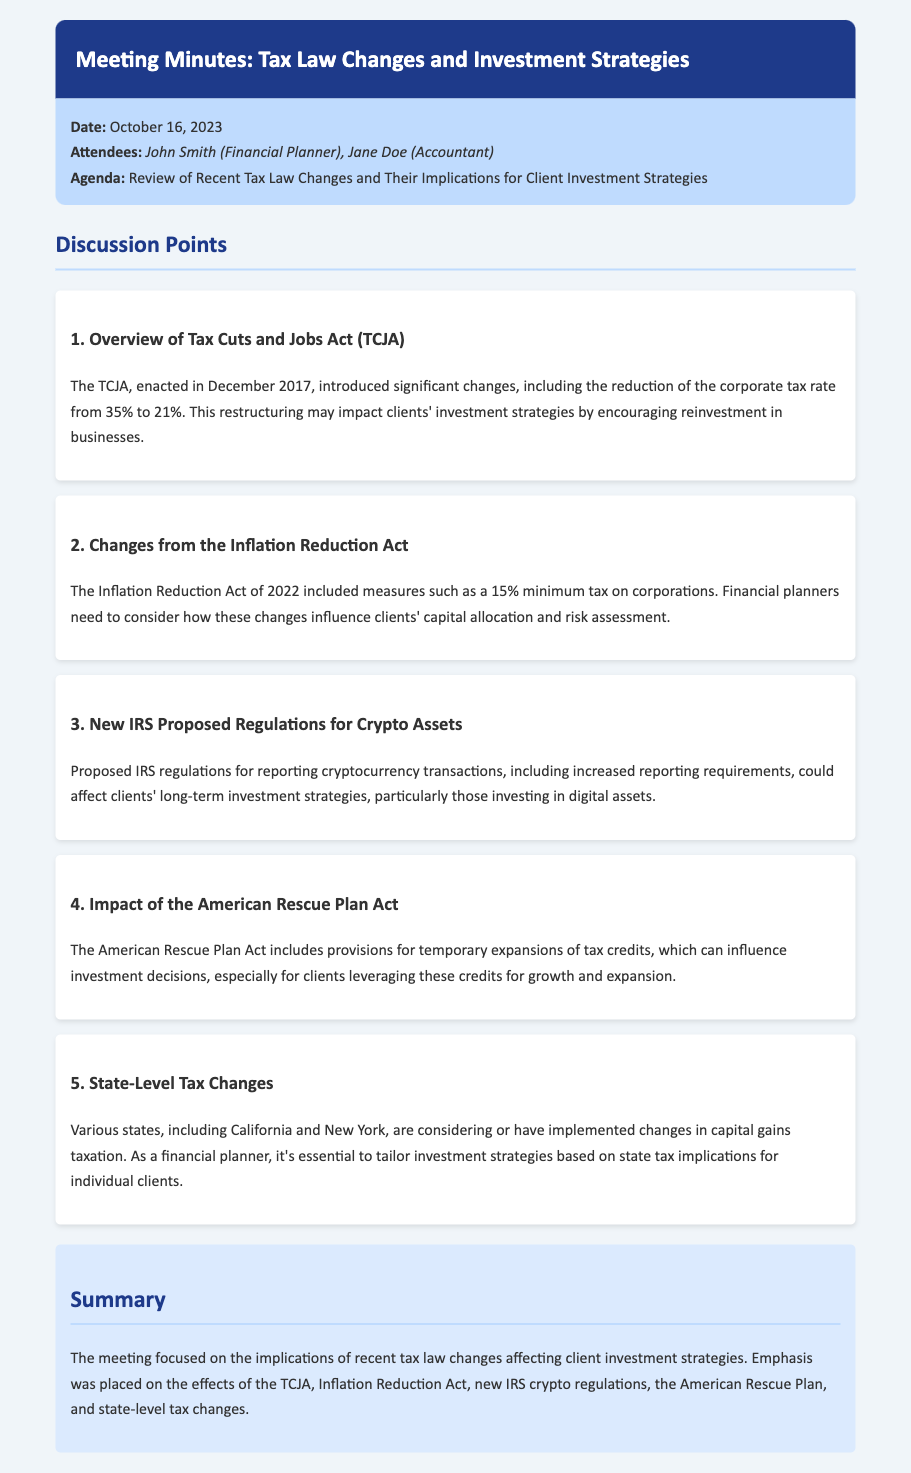What is the date of the meeting? The date of the meeting is explicitly mentioned in the document.
Answer: October 16, 2023 Who are the attendees of the meeting? The attendees are listed in the meta-info section of the document.
Answer: John Smith (Financial Planner), Jane Doe (Accountant) What major tax act was discussed that reduced the corporate tax rate? The document mentions a specific act that introduced this significant change.
Answer: Tax Cuts and Jobs Act (TCJA) What new minimum tax was introduced by the Inflation Reduction Act? The document provides specific details about the minimum tax enacted by this law.
Answer: 15% Which recent legislation includes temporary expansions of tax credits? The document specifically mentions a legislative act that includes these provisions.
Answer: American Rescue Plan Act What state tax implications are relevant for financial planners? The discussion highlights specific states that are considering changes affecting capital gains taxation.
Answer: California and New York How could new IRS proposed regulations affect clients? The document describes a specific area that might influence clients' investment strategies.
Answer: Cryptocurrency transactions What is a key understanding for financial planners regarding capital allocation? The document suggests a consideration for financial planners based on recent tax law adjustments.
Answer: Inflation Reduction Act 